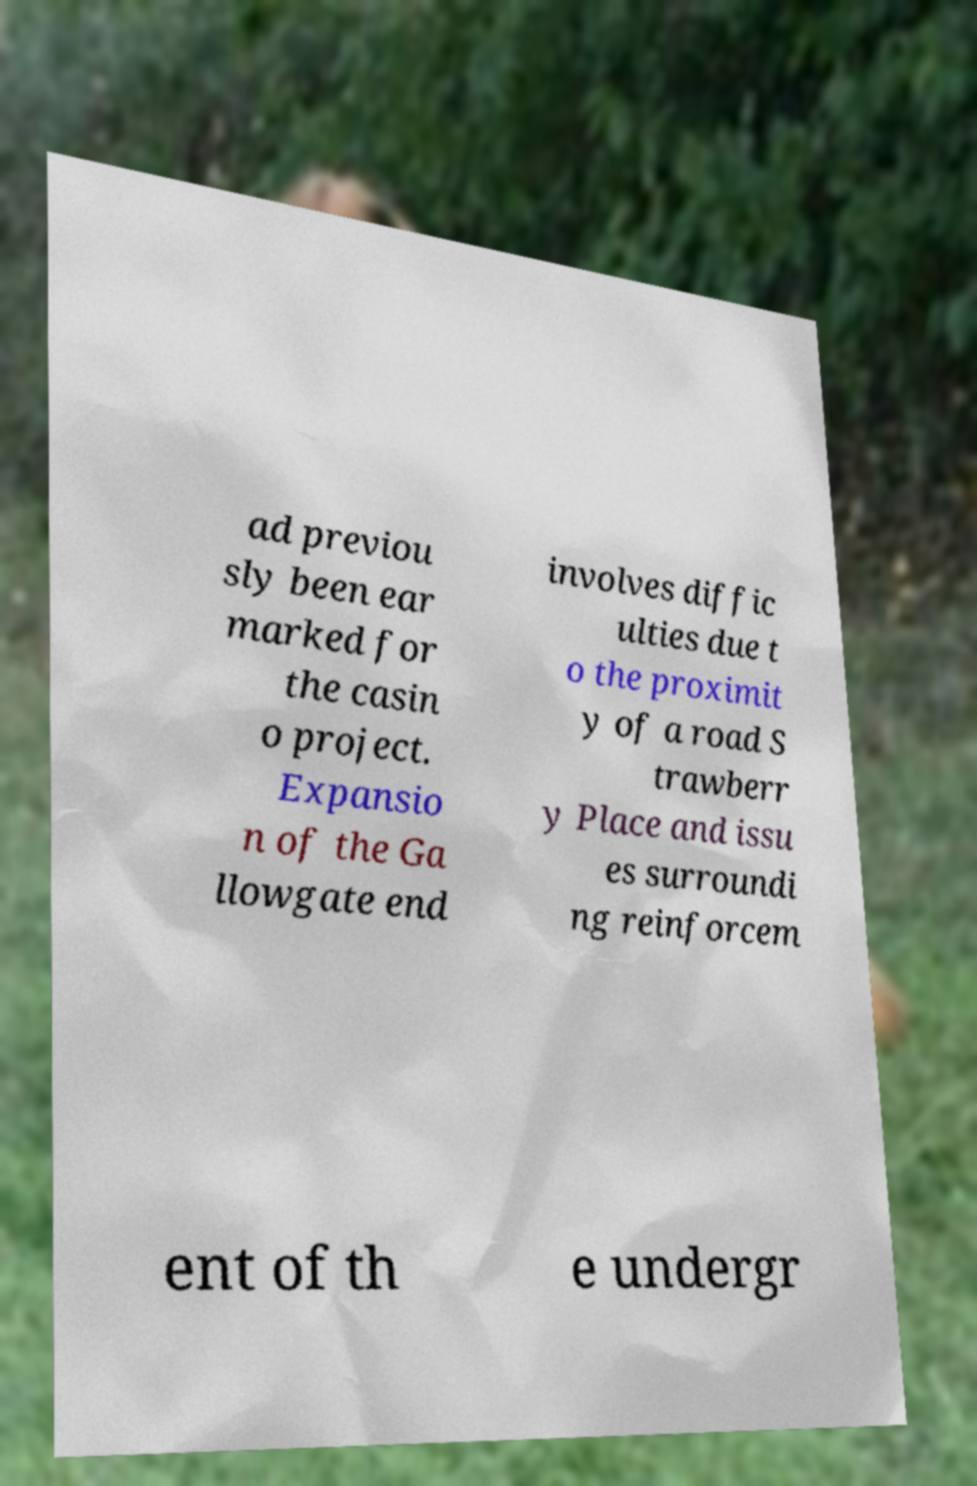Please read and relay the text visible in this image. What does it say? ad previou sly been ear marked for the casin o project. Expansio n of the Ga llowgate end involves diffic ulties due t o the proximit y of a road S trawberr y Place and issu es surroundi ng reinforcem ent of th e undergr 